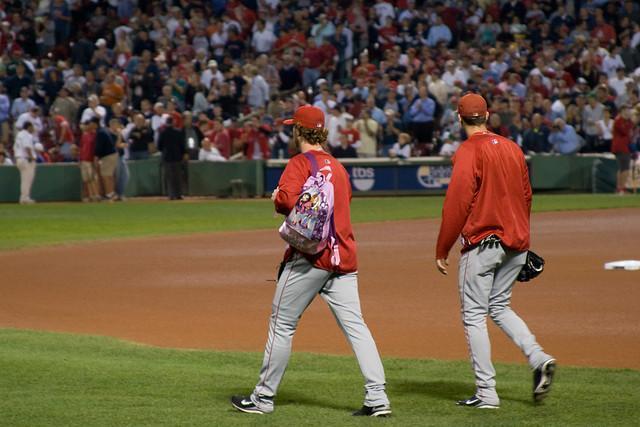How many people are on the field?
Give a very brief answer. 2. How many players are on the field?
Give a very brief answer. 2. How many people are there?
Give a very brief answer. 3. 